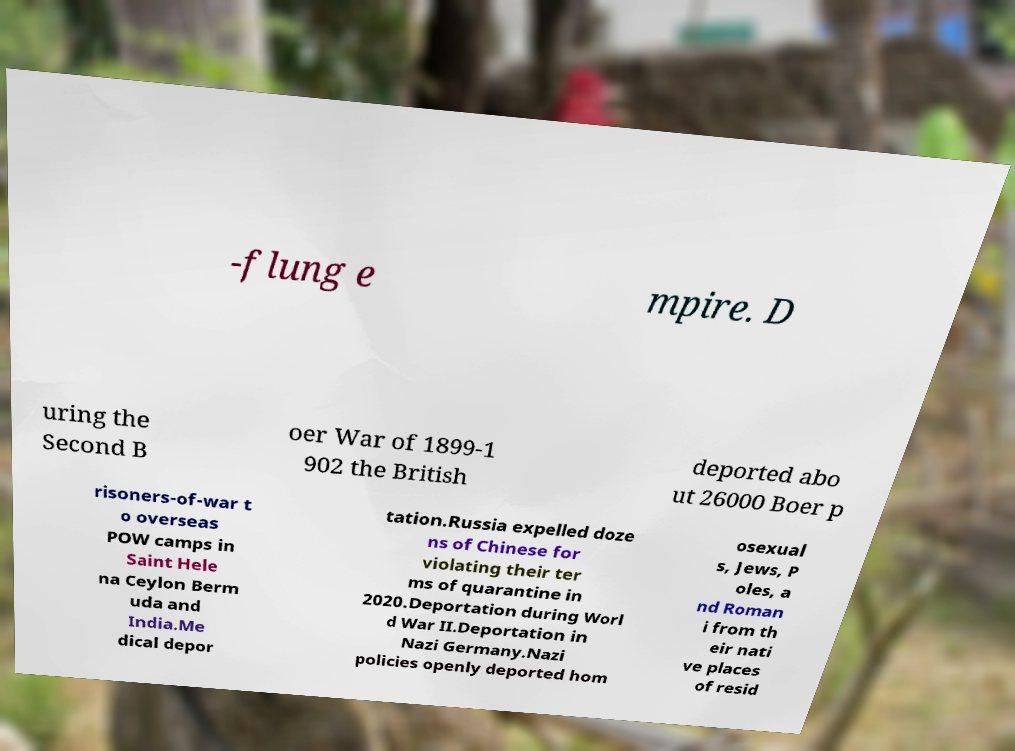For documentation purposes, I need the text within this image transcribed. Could you provide that? -flung e mpire. D uring the Second B oer War of 1899-1 902 the British deported abo ut 26000 Boer p risoners-of-war t o overseas POW camps in Saint Hele na Ceylon Berm uda and India.Me dical depor tation.Russia expelled doze ns of Chinese for violating their ter ms of quarantine in 2020.Deportation during Worl d War II.Deportation in Nazi Germany.Nazi policies openly deported hom osexual s, Jews, P oles, a nd Roman i from th eir nati ve places of resid 